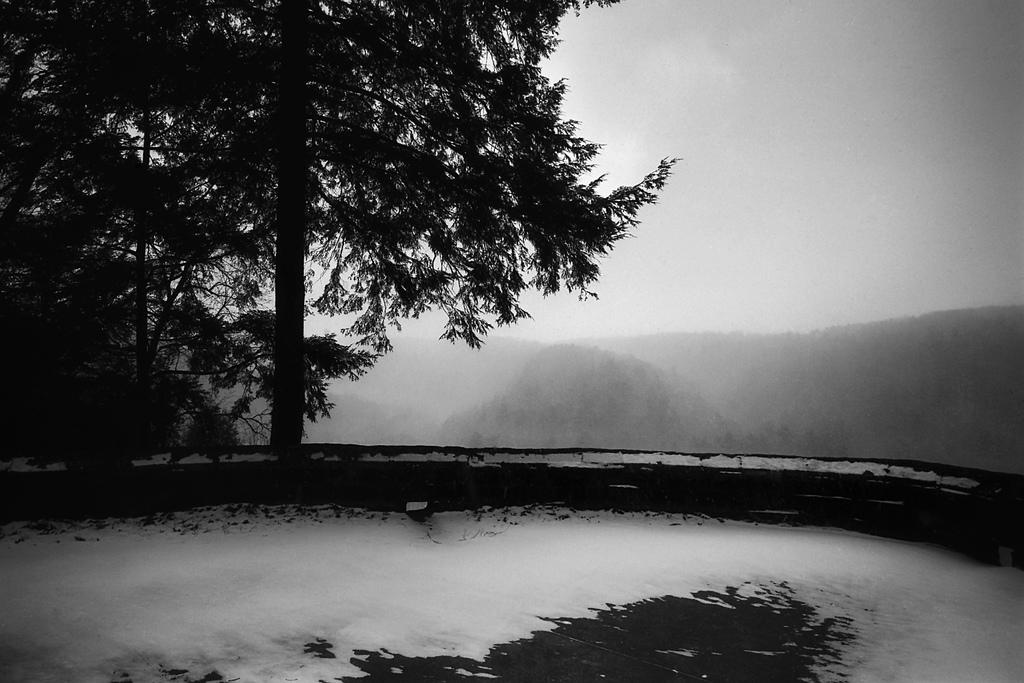What is present in the foreground of the image? In the foreground of the image, there is snow, a road, and a tree. Can you describe the road in the image? The road is visible in the foreground of the image. What can be observed about the background of the image? The background of the image is not clear and appears smoky. What type of lead is being used to create the fictional story in the image? There is no lead or fictional story present in the image; it features snow, a road, and a tree in the foreground, with a smoky background. Can you see a flame in the image? There is no flame present in the image. 